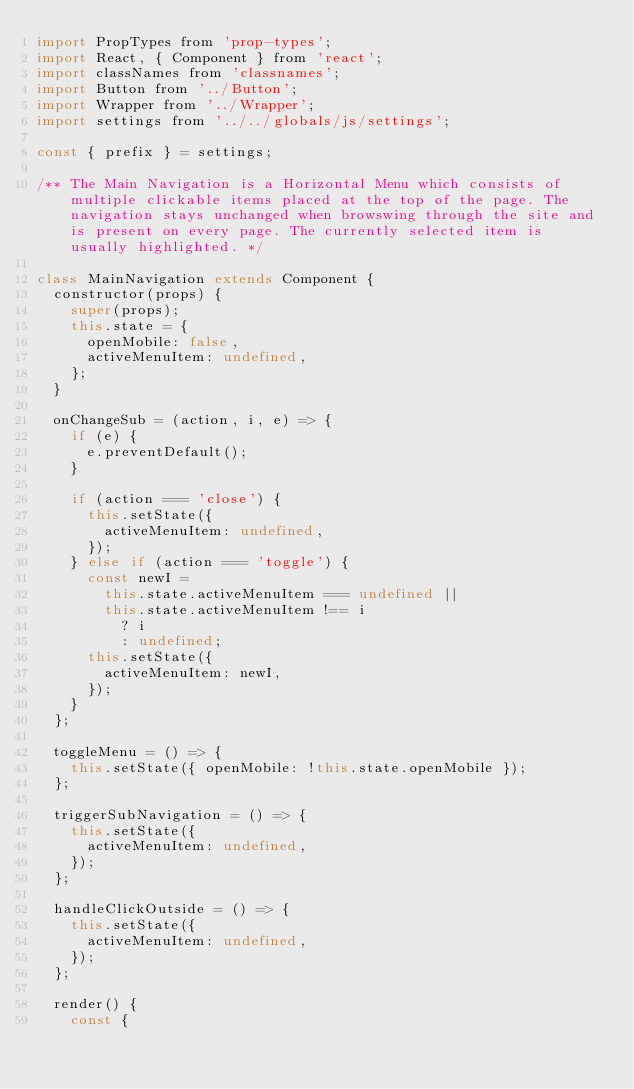<code> <loc_0><loc_0><loc_500><loc_500><_JavaScript_>import PropTypes from 'prop-types';
import React, { Component } from 'react';
import classNames from 'classnames';
import Button from '../Button';
import Wrapper from '../Wrapper';
import settings from '../../globals/js/settings';

const { prefix } = settings;

/** The Main Navigation is a Horizontal Menu which consists of multiple clickable items placed at the top of the page. The navigation stays unchanged when browswing through the site and is present on every page. The currently selected item is usually highlighted. */

class MainNavigation extends Component {
  constructor(props) {
    super(props);
    this.state = {
      openMobile: false,
      activeMenuItem: undefined,
    };
  }

  onChangeSub = (action, i, e) => {
    if (e) {
      e.preventDefault();
    }

    if (action === 'close') {
      this.setState({
        activeMenuItem: undefined,
      });
    } else if (action === 'toggle') {
      const newI =
        this.state.activeMenuItem === undefined ||
        this.state.activeMenuItem !== i
          ? i
          : undefined;
      this.setState({
        activeMenuItem: newI,
      });
    }
  };

  toggleMenu = () => {
    this.setState({ openMobile: !this.state.openMobile });
  };

  triggerSubNavigation = () => {
    this.setState({
      activeMenuItem: undefined,
    });
  };

  handleClickOutside = () => {
    this.setState({
      activeMenuItem: undefined,
    });
  };

  render() {
    const {</code> 